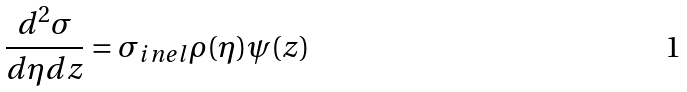<formula> <loc_0><loc_0><loc_500><loc_500>\frac { d ^ { 2 } \sigma } { d \eta d z } = \sigma _ { i n e l } \rho ( \eta ) \psi ( z )</formula> 